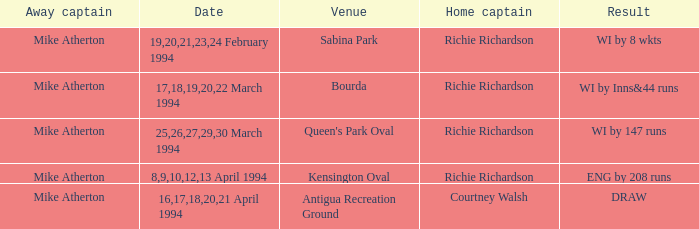Which Home Captain has Venue of Bourda? Richie Richardson. 